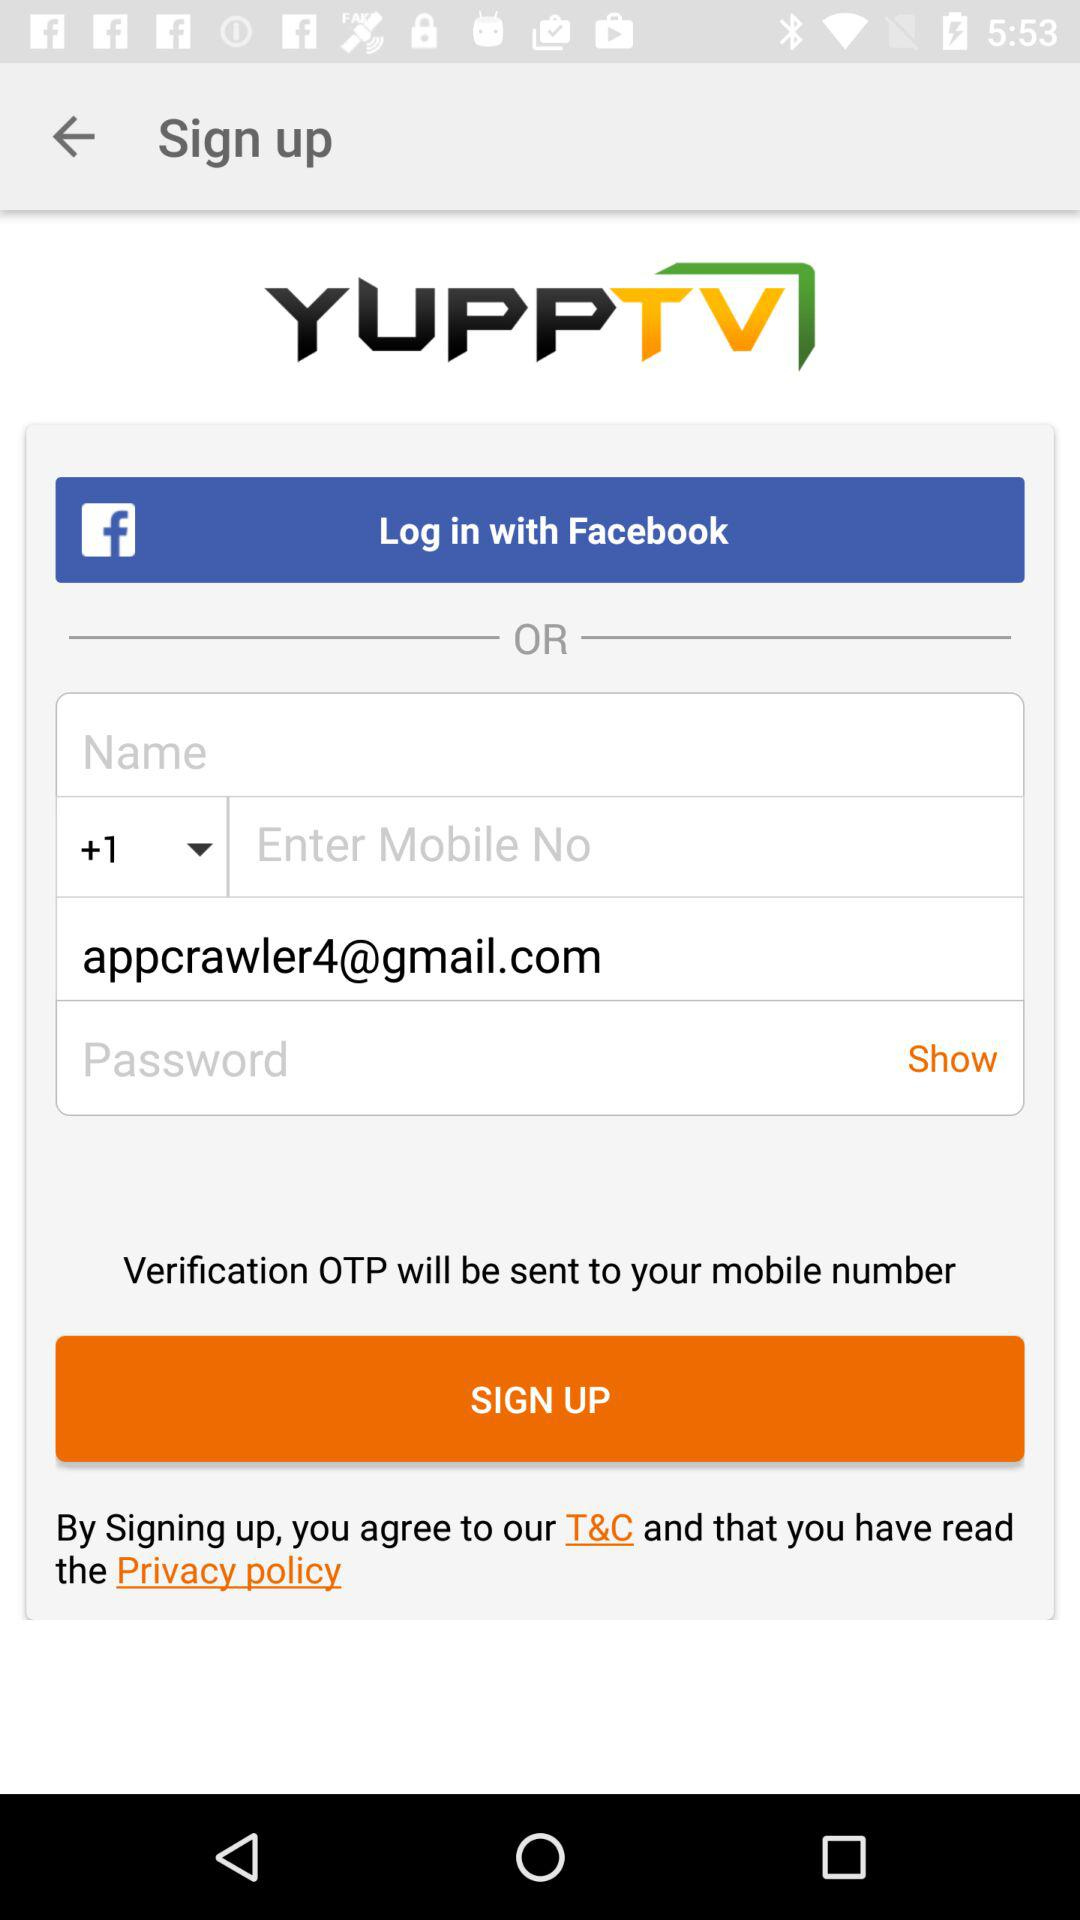Where will the verification OTP be sent? The OTP will be sent to your mobile number. 